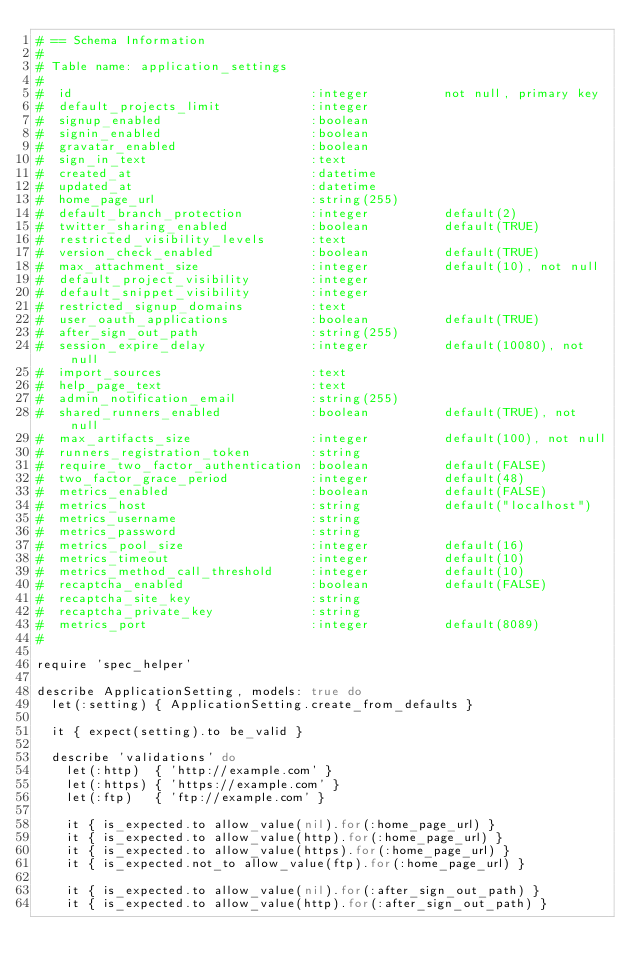<code> <loc_0><loc_0><loc_500><loc_500><_Ruby_># == Schema Information
#
# Table name: application_settings
#
#  id                                :integer          not null, primary key
#  default_projects_limit            :integer
#  signup_enabled                    :boolean
#  signin_enabled                    :boolean
#  gravatar_enabled                  :boolean
#  sign_in_text                      :text
#  created_at                        :datetime
#  updated_at                        :datetime
#  home_page_url                     :string(255)
#  default_branch_protection         :integer          default(2)
#  twitter_sharing_enabled           :boolean          default(TRUE)
#  restricted_visibility_levels      :text
#  version_check_enabled             :boolean          default(TRUE)
#  max_attachment_size               :integer          default(10), not null
#  default_project_visibility        :integer
#  default_snippet_visibility        :integer
#  restricted_signup_domains         :text
#  user_oauth_applications           :boolean          default(TRUE)
#  after_sign_out_path               :string(255)
#  session_expire_delay              :integer          default(10080), not null
#  import_sources                    :text
#  help_page_text                    :text
#  admin_notification_email          :string(255)
#  shared_runners_enabled            :boolean          default(TRUE), not null
#  max_artifacts_size                :integer          default(100), not null
#  runners_registration_token        :string
#  require_two_factor_authentication :boolean          default(FALSE)
#  two_factor_grace_period           :integer          default(48)
#  metrics_enabled                   :boolean          default(FALSE)
#  metrics_host                      :string           default("localhost")
#  metrics_username                  :string
#  metrics_password                  :string
#  metrics_pool_size                 :integer          default(16)
#  metrics_timeout                   :integer          default(10)
#  metrics_method_call_threshold     :integer          default(10)
#  recaptcha_enabled                 :boolean          default(FALSE)
#  recaptcha_site_key                :string
#  recaptcha_private_key             :string
#  metrics_port                      :integer          default(8089)
#

require 'spec_helper'

describe ApplicationSetting, models: true do
  let(:setting) { ApplicationSetting.create_from_defaults }

  it { expect(setting).to be_valid }

  describe 'validations' do
    let(:http)  { 'http://example.com' }
    let(:https) { 'https://example.com' }
    let(:ftp)   { 'ftp://example.com' }

    it { is_expected.to allow_value(nil).for(:home_page_url) }
    it { is_expected.to allow_value(http).for(:home_page_url) }
    it { is_expected.to allow_value(https).for(:home_page_url) }
    it { is_expected.not_to allow_value(ftp).for(:home_page_url) }

    it { is_expected.to allow_value(nil).for(:after_sign_out_path) }
    it { is_expected.to allow_value(http).for(:after_sign_out_path) }</code> 